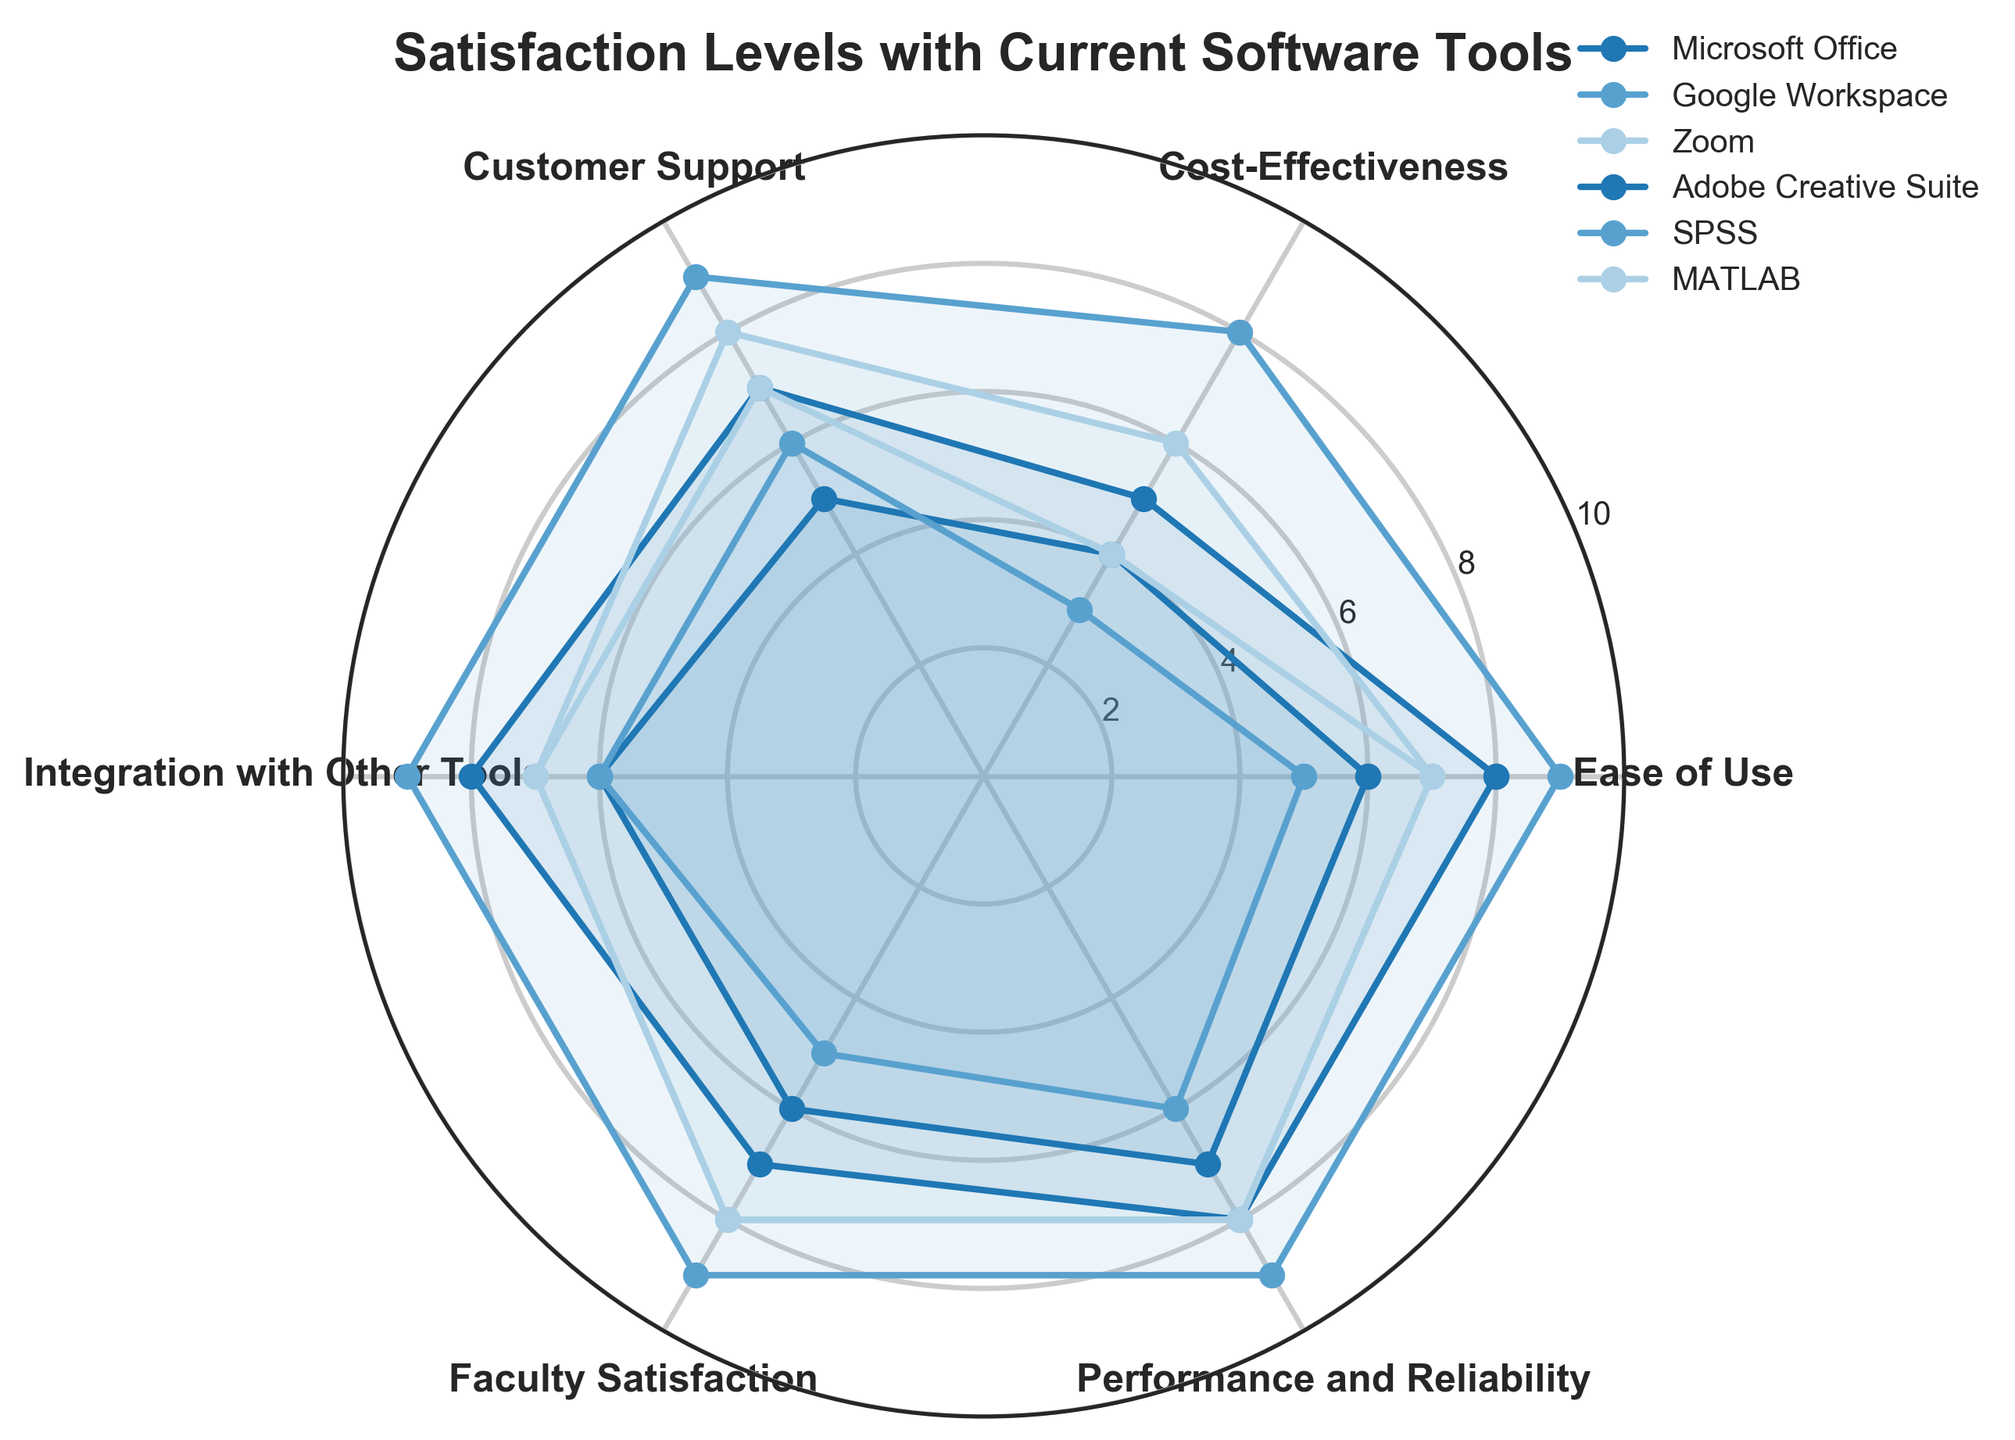What's the title of the radar chart? The title of the radar chart is typically displayed at the top of the figure. It provides an overview of the chart's content.
Answer: Satisfaction Levels with Current Software Tools How many software tools are being compared in the chart? To determine the number of software tools, count the different colored and labeled series on the radar chart.
Answer: 6 Which software tool has the highest rating for “Cost-Effectiveness”? Look at the radial axis corresponding to “Cost-Effectiveness” and identify which software tool reaches the highest value in that direction.
Answer: Google Workspace Which software tool appears to have the most consistent ratings across all categories? Identify the tool where the plotted line appears to be the most evenly shaped and maintains a similar distance from the center across all categories.
Answer: Google Workspace What's the average rating for Faculty Satisfaction across all the software tools? To find the average, add the ratings for Faculty Satisfaction for all tools (7+9+8+6+5+8) and divide by the number of tools (6). (7+9+8+6+5+8) = 43, 43/6 ≈ 7.167
Answer: Approximately 7.17 Which software tool shows the largest difference between “Ease of Use” and “Cost-Effectiveness”? For each tool, subtract the value of “Cost-Effectiveness” from “Ease of Use” and identify the software tool with the largest difference. MATLAB: (7-4 = 3), remaining: Microsoft Office: (8-5=3), Adobe: (6-4=2), SPSS: (5-3=2), Google: (9-8=1), Zoom: (7-6=1)
Answer: Microsoft Office, MATLAB (tie) What is the combined rating of "Integration with Other Tools" for Microsoft Office and Adobe Creative Suite? Combine the ratings by adding up the respective values for “Integration with Other Tools” for Microsoft Office and Adobe Creative Suite. (8 + 6 = 14)
Answer: 14 Which tool has the lowest rating in “Customer Support”? Identify the tool with the lowest point on the radial axis for “Customer Support.”
Answer: Adobe Creative Suite Considering both “Performance and Reliability” and “Faculty Satisfaction,” which software tool performs the best overall? Add the two values for each software tool and compare the totals to determine which has the highest combined score. Microsoft Office: (8+7) = 15; SPSS: (6+5) = 11; Google: (9+9) = 18; Adobe: (7+6) = 13; Zoom: (8+8) = 16; MATLAB: (8+8) = 16
Answer: Google Workspace What is the difference between the highest and lowest rating for “Ease of Use”? Identify the maximum and minimum values for “Ease of Use” from all tools and subtract the lowest from the highest. (9-5)
Answer: 4 